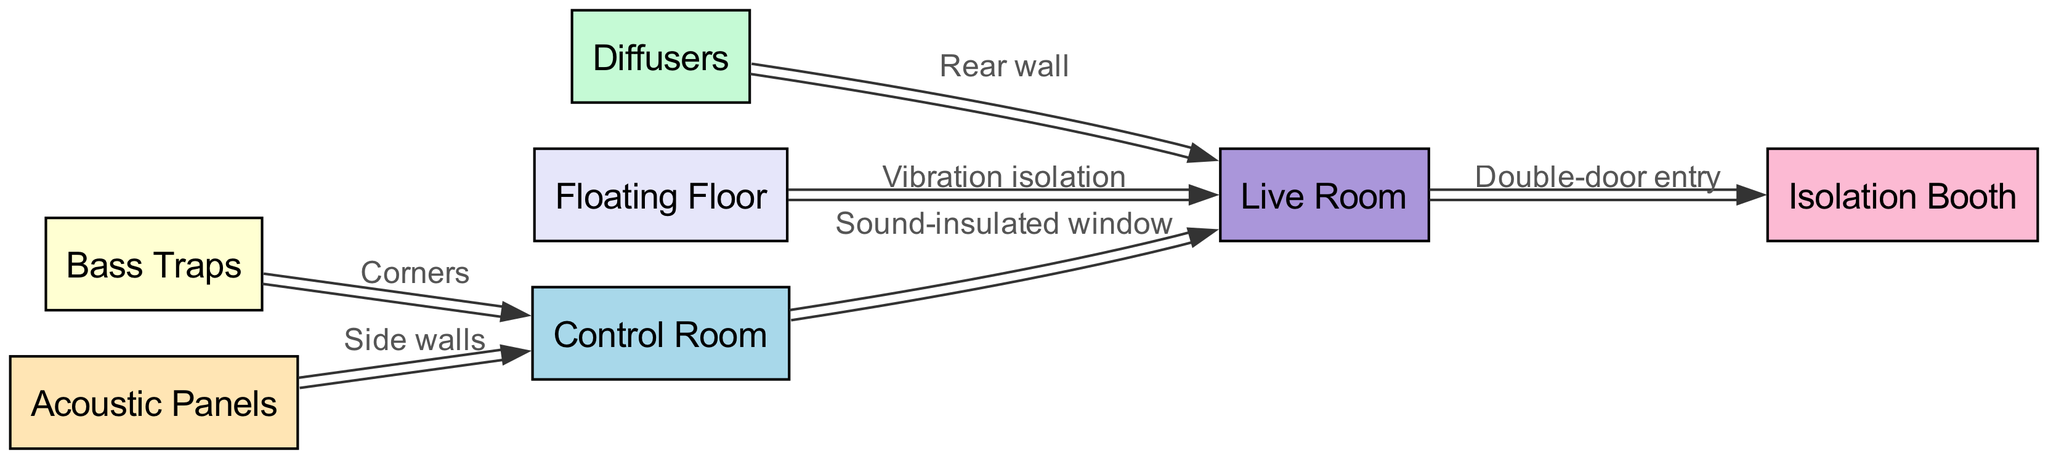What is the central node in the diagram? The central node appears to be the Control Room, as it connects to several other nodes directly, indicating its importance in the acoustic treatment layout.
Answer: Control Room How many nodes are in the diagram? Counting the nodes listed, there are 7 nodes: Control Room, Live Room, Isolation Booth, Bass Traps, Diffusers, Acoustic Panels, and Floating Floor.
Answer: 7 What kind of connection exists between the Control Room and the Live Room? The connection is specified as a "Sound-insulated window," which indicates the physical element that allows for communication while minimizing sound transfer.
Answer: Sound-insulated window Which node is connected to the Live Room with a double-door entry? The node connected to the Live Room with a double-door entry is the Isolation Booth, indicating a designated space for sound isolation.
Answer: Isolation Booth What feature is indicated by the Bass Traps node? Bass Traps are indicated to be placed in the corners of the Control Room, highlighting a specific acoustic treatment method that targets low-frequency sound issues.
Answer: Corners What does the Floating Floor node provide for the Live Room? The Floating Floor is identified as providing "Vibration isolation," which is crucial for minimizing noise transmission from external sources.
Answer: Vibration isolation How are the Acoustic Panels positioned in relation to the Control Room? Acoustic Panels are indicated to be positioned on the Side walls of the Control Room, which suggests their role in controlling reflections and improving sound quality in the space.
Answer: Side walls Which node connects to the Live Room at the Rear wall? The node that connects to the Live Room at the Rear wall is the Diffusers, which serve to scatter sound waves and improve the acoustic environment.
Answer: Diffusers What role do the Diffusers play in the acoustic treatment layout? The Diffusers play a role in scattering sound waves, which helps manage reflections and reduces standing waves, contributing to a more balanced sound environment.
Answer: Scattering sound waves 